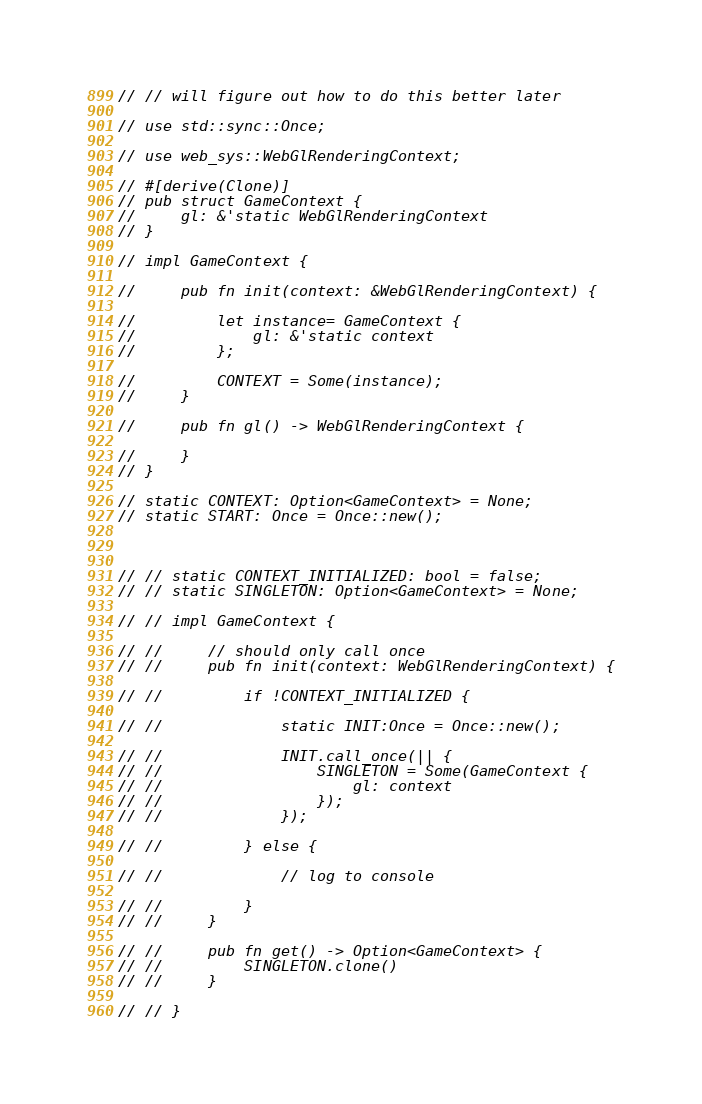Convert code to text. <code><loc_0><loc_0><loc_500><loc_500><_Rust_>
// // will figure out how to do this better later

// use std::sync::Once;

// use web_sys::WebGlRenderingContext;

// #[derive(Clone)]
// pub struct GameContext {
//     gl: &'static WebGlRenderingContext
// }

// impl GameContext {

//     pub fn init(context: &WebGlRenderingContext) {

//         let instance= GameContext {
//             gl: &'static context
//         };

//         CONTEXT = Some(instance);
//     }

//     pub fn gl() -> WebGlRenderingContext {
        
//     }
// }

// static CONTEXT: Option<GameContext> = None;
// static START: Once = Once::new();



// // static CONTEXT_INITIALIZED: bool = false;
// // static SINGLETON: Option<GameContext> = None;

// // impl GameContext {

// //     // should only call once
// //     pub fn init(context: WebGlRenderingContext) {
        
// //         if !CONTEXT_INITIALIZED {

// //             static INIT:Once = Once::new();

// //             INIT.call_once(|| {
// //                 SINGLETON = Some(GameContext {
// //                     gl: context 
// //                 });
// //             });

// //         } else {
            
// //             // log to console

// //         }
// //     }

// //     pub fn get() -> Option<GameContext> {
// //         SINGLETON.clone()
// //     }

// // }</code> 